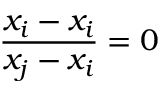<formula> <loc_0><loc_0><loc_500><loc_500>{ \frac { x _ { i } - x _ { i } } { x _ { j } - x _ { i } } } = 0</formula> 